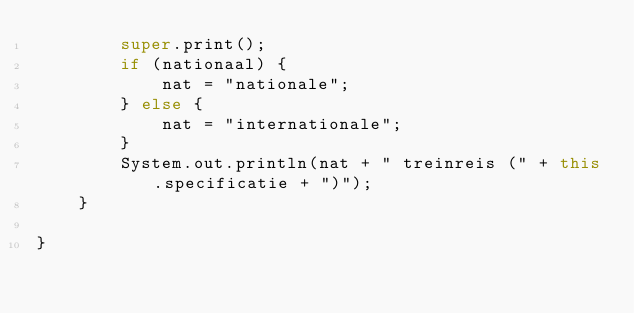Convert code to text. <code><loc_0><loc_0><loc_500><loc_500><_Java_>		super.print();
		if (nationaal) {
			nat = "nationale";
		} else {
			nat = "internationale";
		}
		System.out.println(nat + " treinreis (" + this.specificatie + ")");
	}

}
</code> 